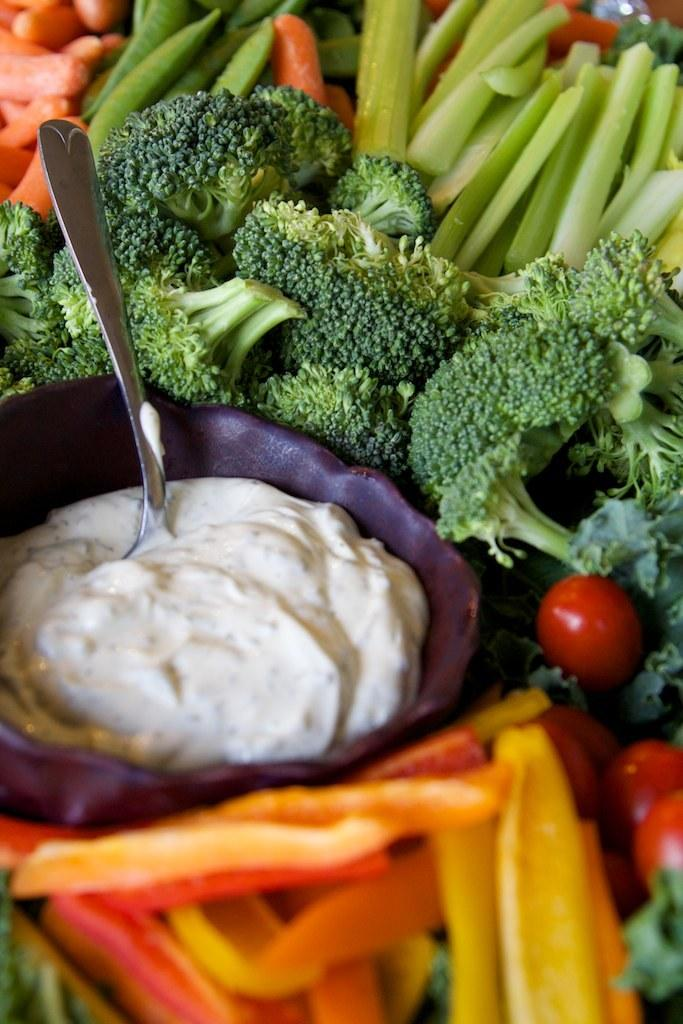What types of food can be seen in the image? There are different types of vegetables in the image. Where is the bowl located in the image? The bowl is on the left side of the image. What is in the bowl? The bowl contains cream. What utensil is present in the bowl? There is a spoon in the bowl. What type of ear can be seen in the image? There is no ear present in the image; it features vegetables, a bowl, cream, and a spoon. What type of mass is being measured in the image? There is no mass being measured in the image; it focuses on vegetables, a bowl, cream, and a spoon. 